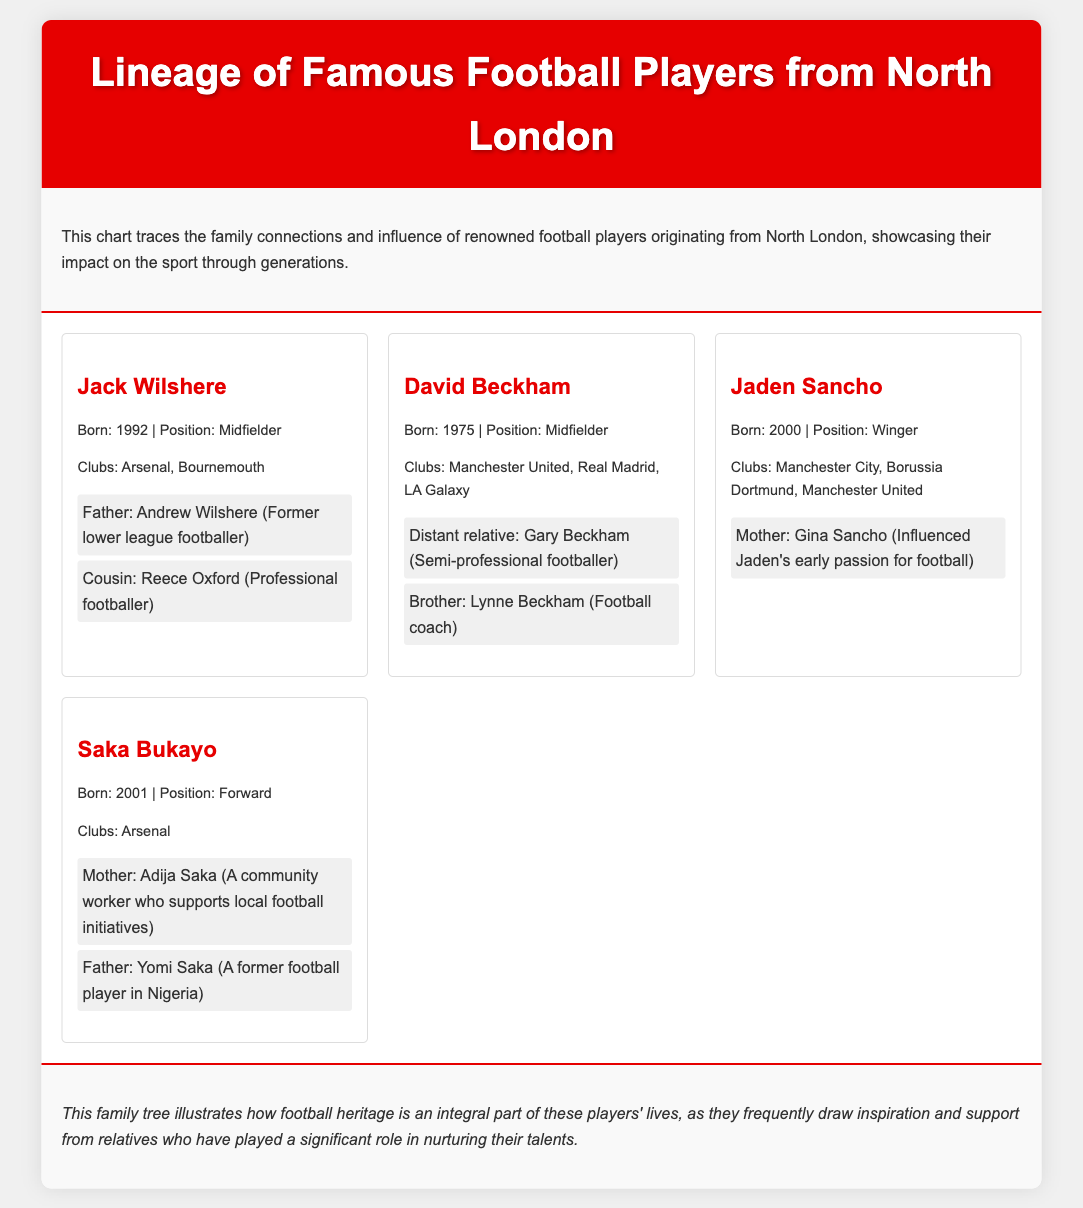what is the birth year of Jack Wilshere? The birth year of Jack Wilshere is specified in the document as 1992.
Answer: 1992 which club did Bukayo Saka play for? The document states that Bukayo Saka played for Arsenal.
Answer: Arsenal who is the mother of Jaden Sancho? The document lists his mother as Gina Sancho.
Answer: Gina Sancho how many family members are listed for David Beckham? The document indicates that there are two family members listed: a distant relative and a brother.
Answer: 2 who influenced Jaden Sancho's early passion for football? According to the document, his mother influenced his early passion.
Answer: Gina Sancho what position does David Beckham play? The position of David Beckham is mentioned as Midfielder in the document.
Answer: Midfielder which family member of Saka Bukayo is described as a community worker? The document describes his mother, Adija Saka, as a community worker.
Answer: Adija Saka how many players are detailed in the lineage chart? The document presents four players in the lineage chart.
Answer: 4 what is the relationship of Reece Oxford to Jack Wilshere? The document states that Reece Oxford is a cousin of Jack Wilshere.
Answer: Cousin 